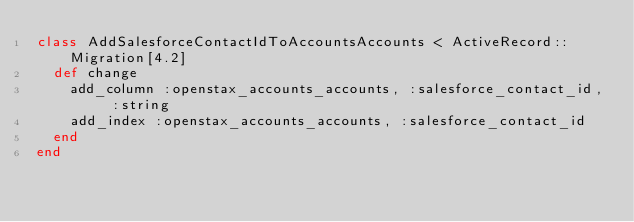<code> <loc_0><loc_0><loc_500><loc_500><_Ruby_>class AddSalesforceContactIdToAccountsAccounts < ActiveRecord::Migration[4.2]
  def change
    add_column :openstax_accounts_accounts, :salesforce_contact_id, :string
    add_index :openstax_accounts_accounts, :salesforce_contact_id
  end
end
</code> 